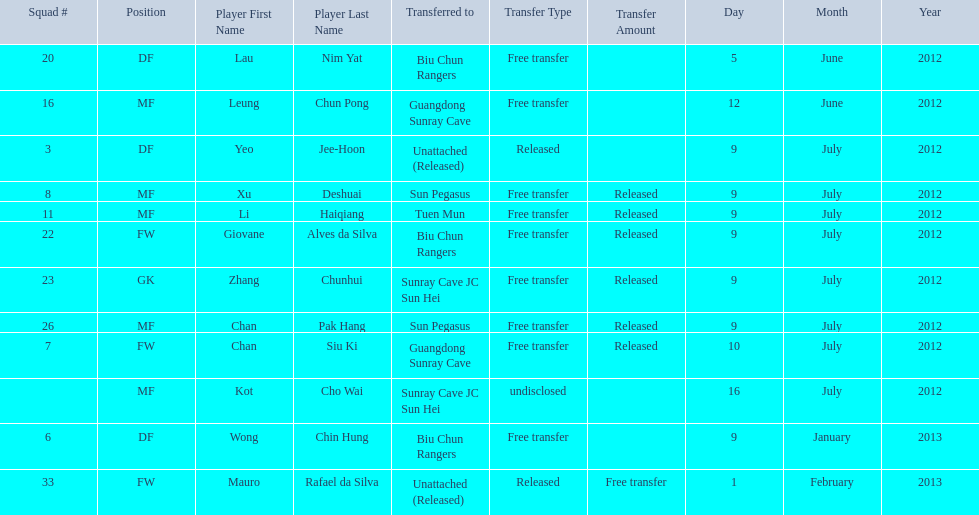On what dates were there non released free transfers? 5 June 2012, 12 June 2012, 9 January 2013, 1 February 2013. On which of these were the players transferred to another team? 5 June 2012, 12 June 2012, 9 January 2013. Which of these were the transfers to biu chun rangers? 5 June 2012, 9 January 2013. On which of those dated did they receive a df? 9 January 2013. 